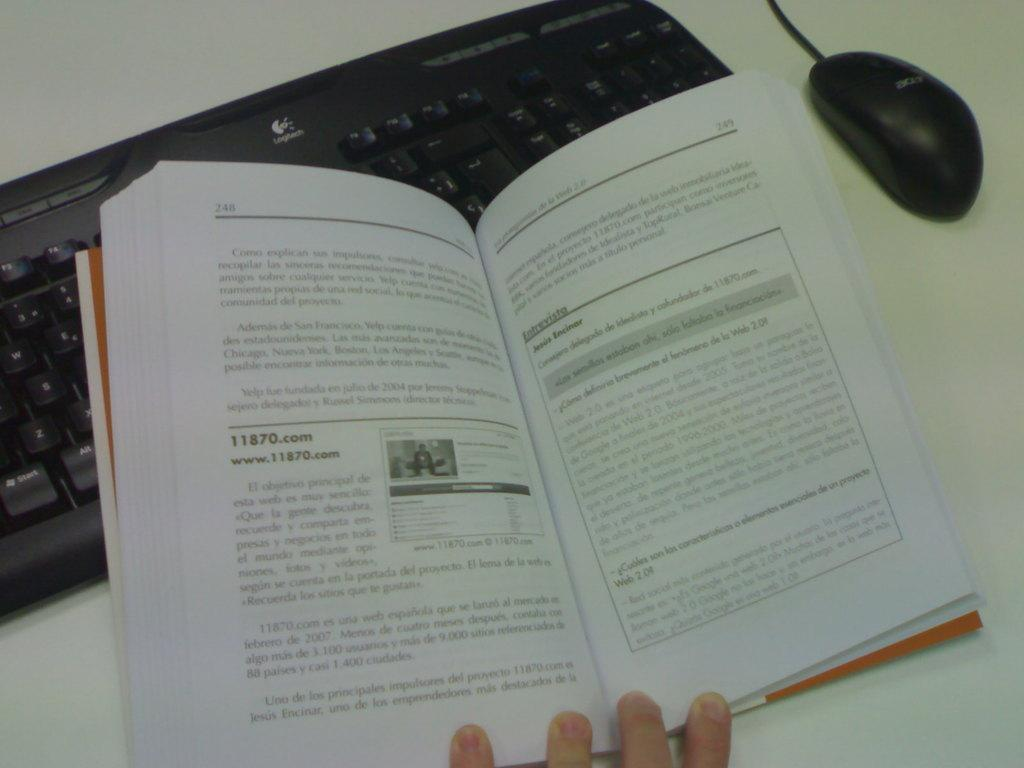<image>
Render a clear and concise summary of the photo. Pages 248 and 249 in a book about 11870.com 